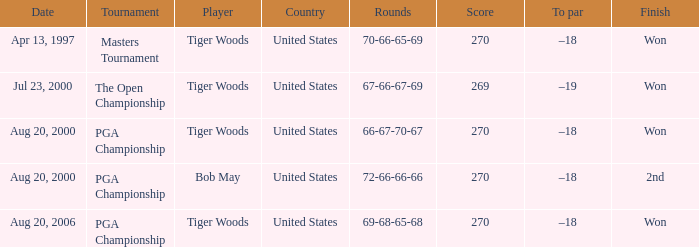What is the most undesirable (top) score? 270.0. 